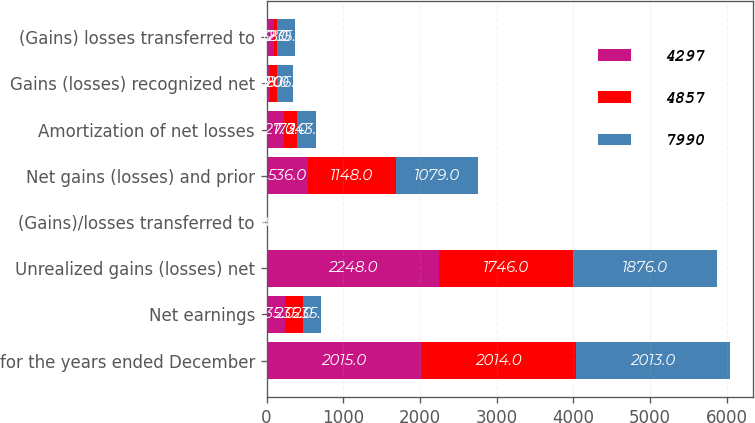Convert chart. <chart><loc_0><loc_0><loc_500><loc_500><stacked_bar_chart><ecel><fcel>for the years ended December<fcel>Net earnings<fcel>Unrealized gains (losses) net<fcel>(Gains)/losses transferred to<fcel>Net gains (losses) and prior<fcel>Amortization of net losses<fcel>Gains (losses) recognized net<fcel>(Gains) losses transferred to<nl><fcel>4297<fcel>2015<fcel>235<fcel>2248<fcel>1<fcel>536<fcel>227<fcel>38<fcel>102<nl><fcel>4857<fcel>2014<fcel>235<fcel>1746<fcel>5<fcel>1148<fcel>173<fcel>98<fcel>38<nl><fcel>7990<fcel>2013<fcel>235<fcel>1876<fcel>12<fcel>1079<fcel>243<fcel>206<fcel>235<nl></chart> 